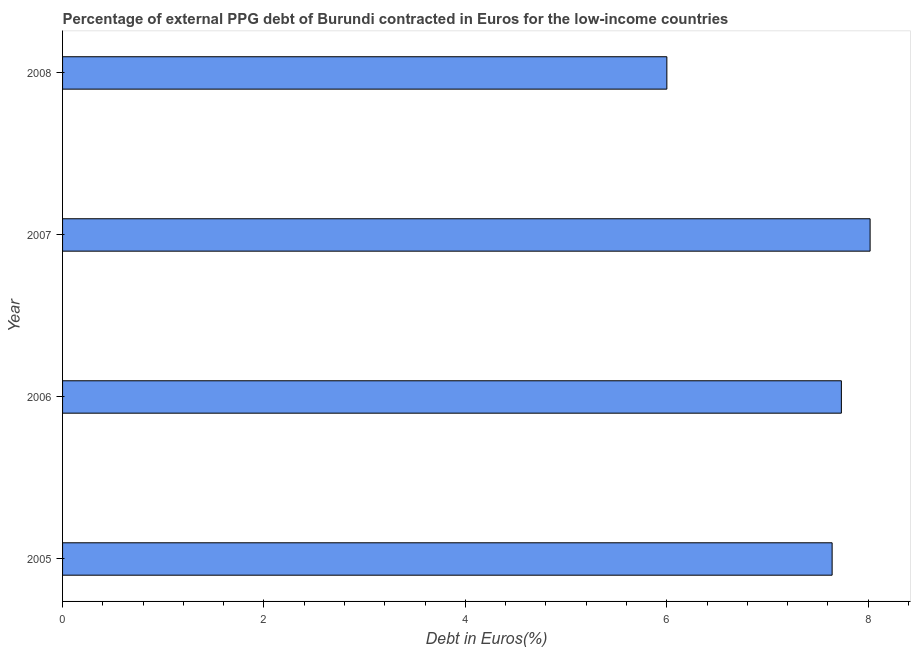Does the graph contain any zero values?
Offer a very short reply. No. Does the graph contain grids?
Offer a terse response. No. What is the title of the graph?
Give a very brief answer. Percentage of external PPG debt of Burundi contracted in Euros for the low-income countries. What is the label or title of the X-axis?
Your answer should be compact. Debt in Euros(%). What is the label or title of the Y-axis?
Keep it short and to the point. Year. What is the currency composition of ppg debt in 2006?
Offer a terse response. 7.73. Across all years, what is the maximum currency composition of ppg debt?
Your answer should be compact. 8.02. Across all years, what is the minimum currency composition of ppg debt?
Your answer should be compact. 6. In which year was the currency composition of ppg debt maximum?
Keep it short and to the point. 2007. In which year was the currency composition of ppg debt minimum?
Make the answer very short. 2008. What is the sum of the currency composition of ppg debt?
Ensure brevity in your answer.  29.39. What is the difference between the currency composition of ppg debt in 2006 and 2007?
Offer a very short reply. -0.28. What is the average currency composition of ppg debt per year?
Provide a short and direct response. 7.35. What is the median currency composition of ppg debt?
Your answer should be compact. 7.69. In how many years, is the currency composition of ppg debt greater than 2.8 %?
Keep it short and to the point. 4. Do a majority of the years between 2007 and 2005 (inclusive) have currency composition of ppg debt greater than 1.2 %?
Offer a very short reply. Yes. What is the ratio of the currency composition of ppg debt in 2005 to that in 2006?
Offer a terse response. 0.99. What is the difference between the highest and the second highest currency composition of ppg debt?
Give a very brief answer. 0.28. What is the difference between the highest and the lowest currency composition of ppg debt?
Make the answer very short. 2.02. How many bars are there?
Provide a short and direct response. 4. Are all the bars in the graph horizontal?
Provide a succinct answer. Yes. What is the Debt in Euros(%) of 2005?
Keep it short and to the point. 7.64. What is the Debt in Euros(%) of 2006?
Make the answer very short. 7.73. What is the Debt in Euros(%) of 2007?
Your answer should be compact. 8.02. What is the Debt in Euros(%) in 2008?
Keep it short and to the point. 6. What is the difference between the Debt in Euros(%) in 2005 and 2006?
Your response must be concise. -0.09. What is the difference between the Debt in Euros(%) in 2005 and 2007?
Your response must be concise. -0.38. What is the difference between the Debt in Euros(%) in 2005 and 2008?
Offer a terse response. 1.64. What is the difference between the Debt in Euros(%) in 2006 and 2007?
Keep it short and to the point. -0.29. What is the difference between the Debt in Euros(%) in 2006 and 2008?
Provide a succinct answer. 1.73. What is the difference between the Debt in Euros(%) in 2007 and 2008?
Your answer should be very brief. 2.02. What is the ratio of the Debt in Euros(%) in 2005 to that in 2007?
Give a very brief answer. 0.95. What is the ratio of the Debt in Euros(%) in 2005 to that in 2008?
Make the answer very short. 1.27. What is the ratio of the Debt in Euros(%) in 2006 to that in 2008?
Offer a terse response. 1.29. What is the ratio of the Debt in Euros(%) in 2007 to that in 2008?
Provide a short and direct response. 1.34. 